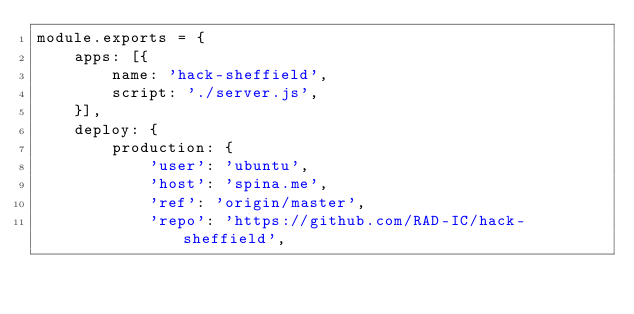Convert code to text. <code><loc_0><loc_0><loc_500><loc_500><_JavaScript_>module.exports = {
    apps: [{
        name: 'hack-sheffield',
        script: './server.js',
    }],
    deploy: {
        production: {
            'user': 'ubuntu',
            'host': 'spina.me',
            'ref': 'origin/master',
            'repo': 'https://github.com/RAD-IC/hack-sheffield',</code> 